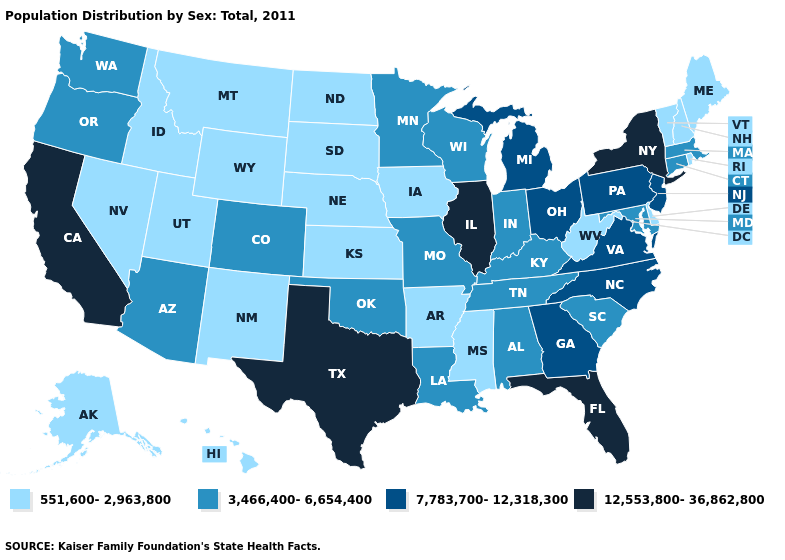What is the highest value in states that border Louisiana?
Quick response, please. 12,553,800-36,862,800. Which states have the lowest value in the South?
Quick response, please. Arkansas, Delaware, Mississippi, West Virginia. What is the value of Michigan?
Answer briefly. 7,783,700-12,318,300. Which states have the lowest value in the USA?
Quick response, please. Alaska, Arkansas, Delaware, Hawaii, Idaho, Iowa, Kansas, Maine, Mississippi, Montana, Nebraska, Nevada, New Hampshire, New Mexico, North Dakota, Rhode Island, South Dakota, Utah, Vermont, West Virginia, Wyoming. What is the value of Pennsylvania?
Short answer required. 7,783,700-12,318,300. What is the highest value in states that border Utah?
Short answer required. 3,466,400-6,654,400. Name the states that have a value in the range 7,783,700-12,318,300?
Quick response, please. Georgia, Michigan, New Jersey, North Carolina, Ohio, Pennsylvania, Virginia. What is the highest value in states that border New Hampshire?
Keep it brief. 3,466,400-6,654,400. Which states have the highest value in the USA?
Concise answer only. California, Florida, Illinois, New York, Texas. Does Florida have the highest value in the USA?
Be succinct. Yes. Which states hav the highest value in the MidWest?
Be succinct. Illinois. Does North Carolina have the same value as New Mexico?
Write a very short answer. No. Does Utah have the highest value in the USA?
Keep it brief. No. Name the states that have a value in the range 551,600-2,963,800?
Write a very short answer. Alaska, Arkansas, Delaware, Hawaii, Idaho, Iowa, Kansas, Maine, Mississippi, Montana, Nebraska, Nevada, New Hampshire, New Mexico, North Dakota, Rhode Island, South Dakota, Utah, Vermont, West Virginia, Wyoming. Name the states that have a value in the range 3,466,400-6,654,400?
Be succinct. Alabama, Arizona, Colorado, Connecticut, Indiana, Kentucky, Louisiana, Maryland, Massachusetts, Minnesota, Missouri, Oklahoma, Oregon, South Carolina, Tennessee, Washington, Wisconsin. 